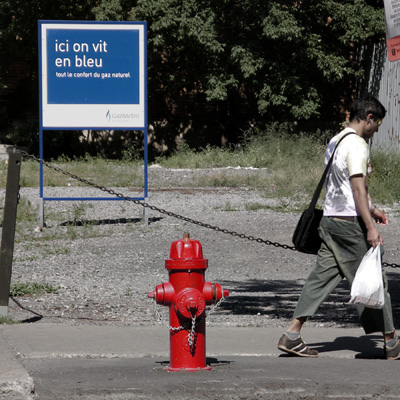Read all the text in this image. ici on vit en bleu 